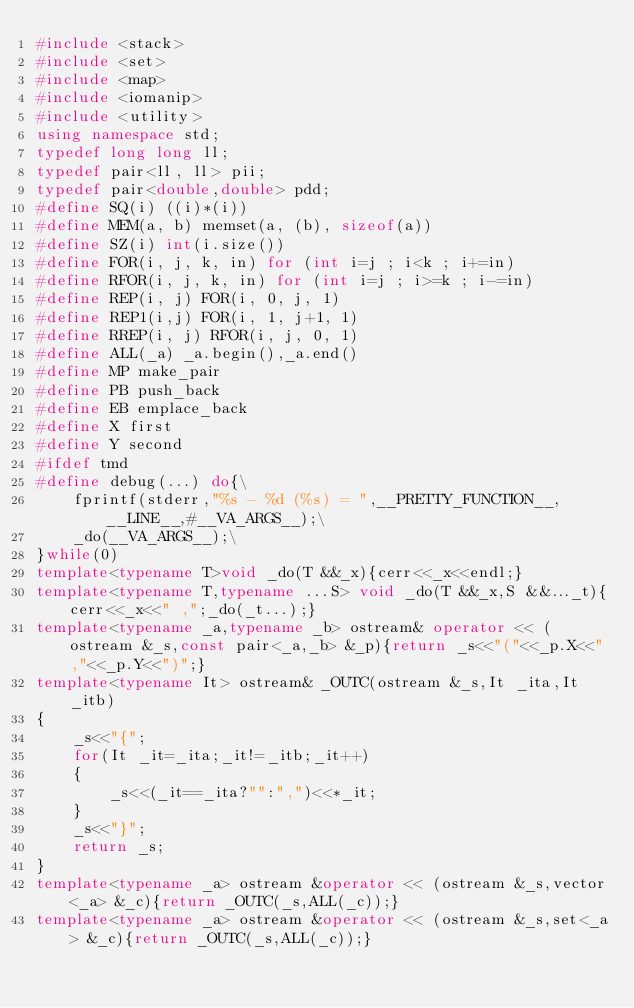Convert code to text. <code><loc_0><loc_0><loc_500><loc_500><_C++_>#include <stack>
#include <set>
#include <map>
#include <iomanip> 
#include <utility>
using namespace std;
typedef long long ll;
typedef pair<ll, ll> pii;
typedef pair<double,double> pdd;
#define SQ(i) ((i)*(i))
#define MEM(a, b) memset(a, (b), sizeof(a))
#define SZ(i) int(i.size())
#define FOR(i, j, k, in) for (int i=j ; i<k ; i+=in)
#define RFOR(i, j, k, in) for (int i=j ; i>=k ; i-=in)
#define REP(i, j) FOR(i, 0, j, 1)
#define REP1(i,j) FOR(i, 1, j+1, 1)
#define RREP(i, j) RFOR(i, j, 0, 1)
#define ALL(_a) _a.begin(),_a.end()
#define MP make_pair
#define PB push_back
#define EB emplace_back
#define X first
#define Y second
#ifdef tmd
#define debug(...) do{\
    fprintf(stderr,"%s - %d (%s) = ",__PRETTY_FUNCTION__,__LINE__,#__VA_ARGS__);\
    _do(__VA_ARGS__);\
}while(0)
template<typename T>void _do(T &&_x){cerr<<_x<<endl;}
template<typename T,typename ...S> void _do(T &&_x,S &&..._t){cerr<<_x<<" ,";_do(_t...);}
template<typename _a,typename _b> ostream& operator << (ostream &_s,const pair<_a,_b> &_p){return _s<<"("<<_p.X<<","<<_p.Y<<")";}
template<typename It> ostream& _OUTC(ostream &_s,It _ita,It _itb)
{
    _s<<"{";
    for(It _it=_ita;_it!=_itb;_it++)
    {
        _s<<(_it==_ita?"":",")<<*_it;
    }
    _s<<"}";
    return _s;
}
template<typename _a> ostream &operator << (ostream &_s,vector<_a> &_c){return _OUTC(_s,ALL(_c));}
template<typename _a> ostream &operator << (ostream &_s,set<_a> &_c){return _OUTC(_s,ALL(_c));}</code> 